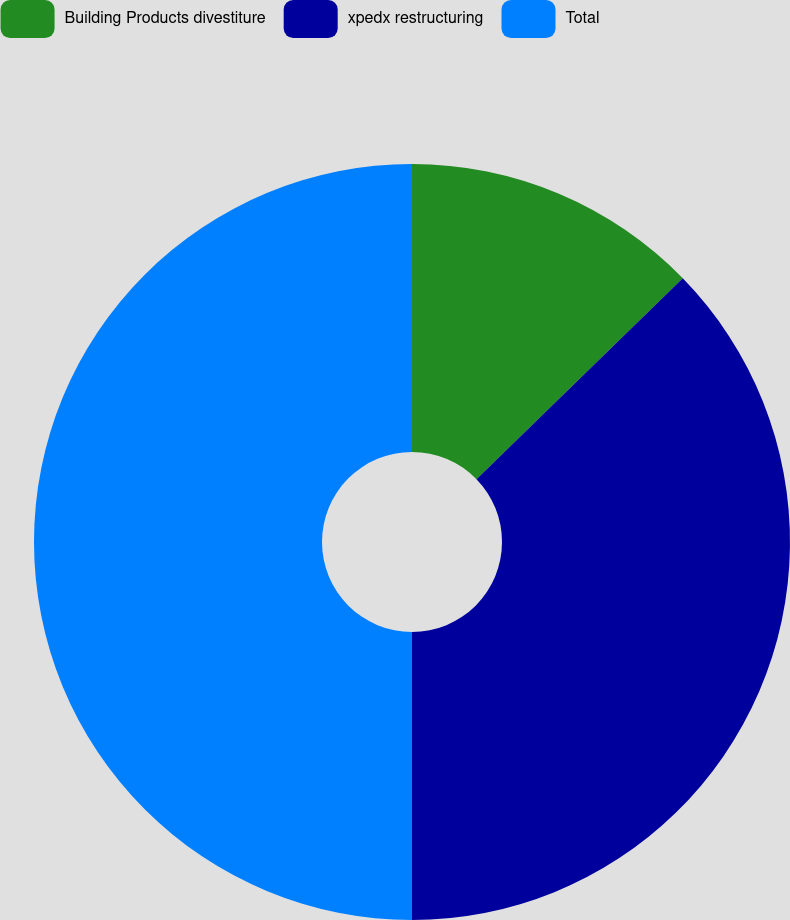<chart> <loc_0><loc_0><loc_500><loc_500><pie_chart><fcel>Building Products divestiture<fcel>xpedx restructuring<fcel>Total<nl><fcel>12.71%<fcel>37.29%<fcel>50.0%<nl></chart> 